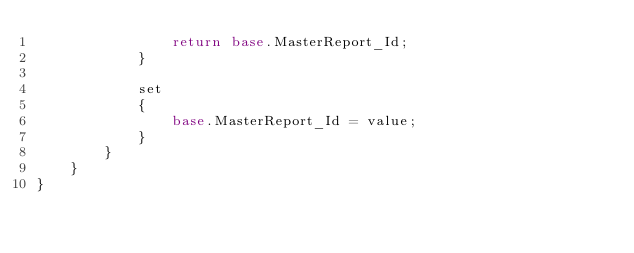<code> <loc_0><loc_0><loc_500><loc_500><_C#_>                return base.MasterReport_Id;
            }

            set
            {
                base.MasterReport_Id = value;
            }
        }
    }
}</code> 